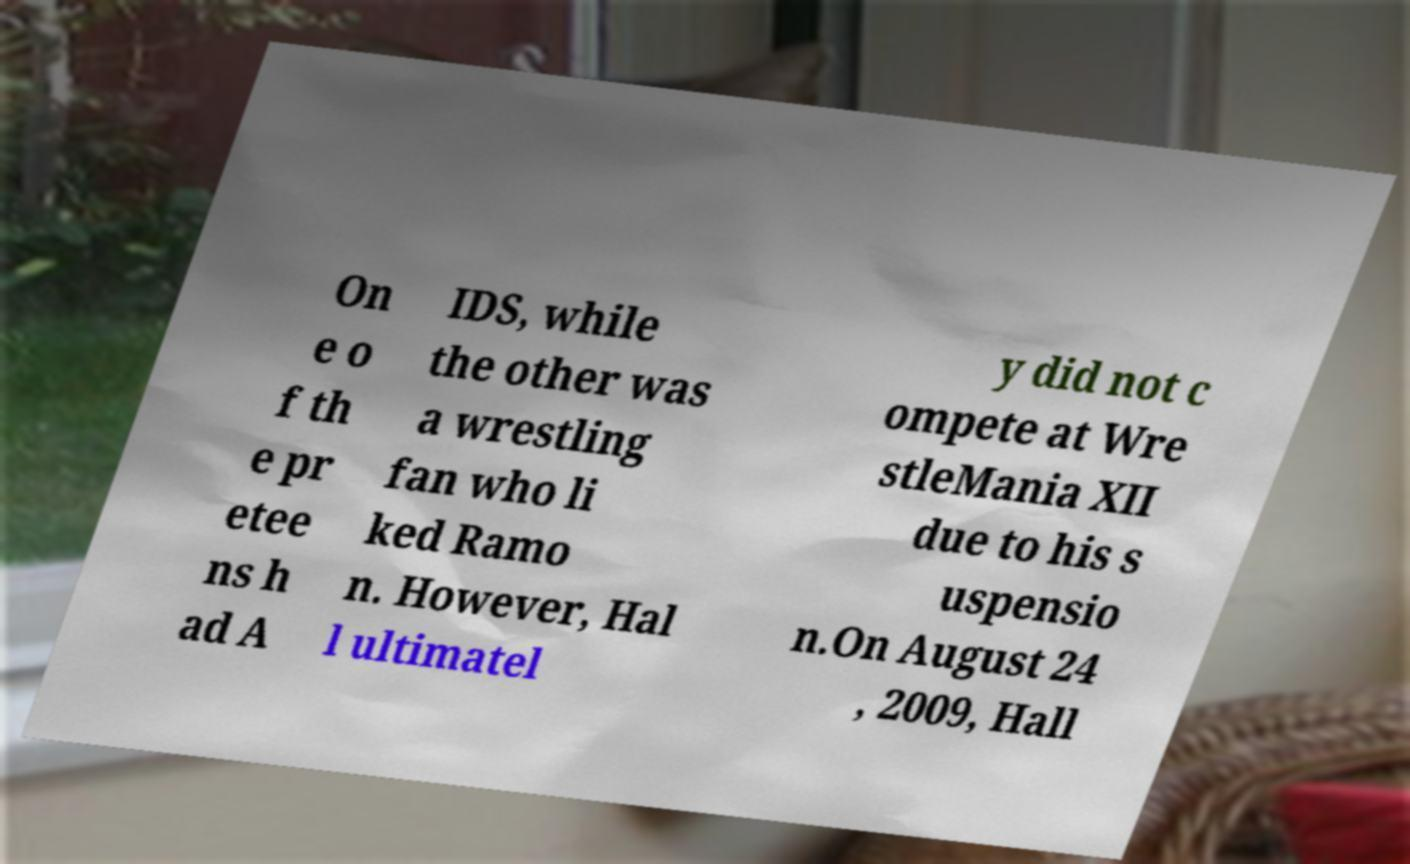There's text embedded in this image that I need extracted. Can you transcribe it verbatim? On e o f th e pr etee ns h ad A IDS, while the other was a wrestling fan who li ked Ramo n. However, Hal l ultimatel y did not c ompete at Wre stleMania XII due to his s uspensio n.On August 24 , 2009, Hall 